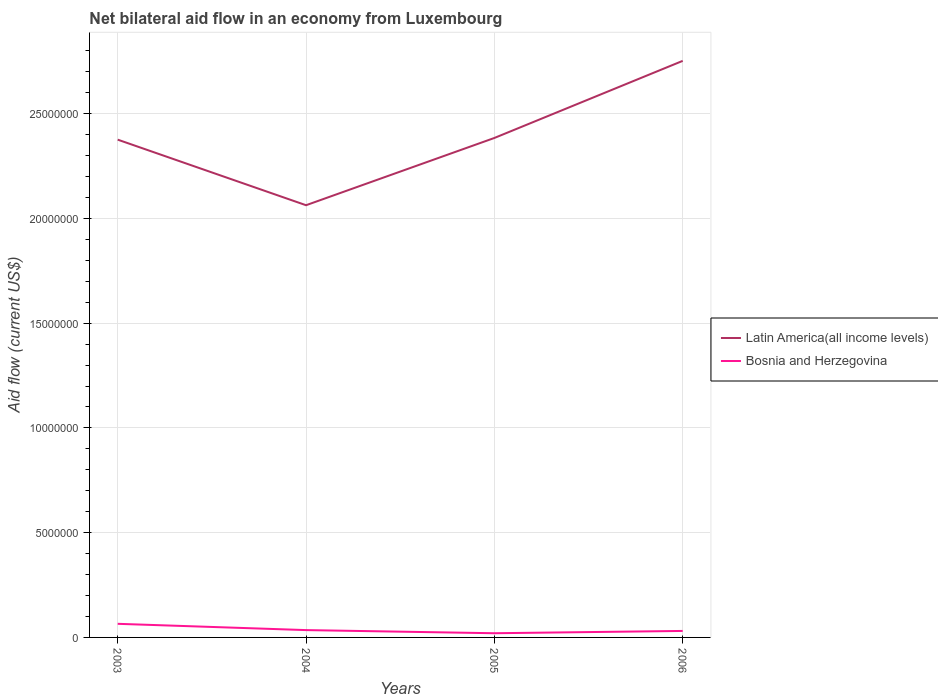Does the line corresponding to Bosnia and Herzegovina intersect with the line corresponding to Latin America(all income levels)?
Your answer should be very brief. No. Across all years, what is the maximum net bilateral aid flow in Bosnia and Herzegovina?
Provide a short and direct response. 2.00e+05. What is the total net bilateral aid flow in Bosnia and Herzegovina in the graph?
Ensure brevity in your answer.  1.50e+05. What is the difference between the highest and the second highest net bilateral aid flow in Bosnia and Herzegovina?
Give a very brief answer. 4.50e+05. What is the difference between the highest and the lowest net bilateral aid flow in Latin America(all income levels)?
Offer a very short reply. 1. Is the net bilateral aid flow in Latin America(all income levels) strictly greater than the net bilateral aid flow in Bosnia and Herzegovina over the years?
Your answer should be very brief. No. What is the difference between two consecutive major ticks on the Y-axis?
Provide a succinct answer. 5.00e+06. Does the graph contain any zero values?
Provide a succinct answer. No. Does the graph contain grids?
Provide a short and direct response. Yes. Where does the legend appear in the graph?
Keep it short and to the point. Center right. How many legend labels are there?
Keep it short and to the point. 2. What is the title of the graph?
Your answer should be compact. Net bilateral aid flow in an economy from Luxembourg. What is the label or title of the X-axis?
Your answer should be compact. Years. What is the label or title of the Y-axis?
Keep it short and to the point. Aid flow (current US$). What is the Aid flow (current US$) in Latin America(all income levels) in 2003?
Your answer should be compact. 2.38e+07. What is the Aid flow (current US$) in Bosnia and Herzegovina in 2003?
Your answer should be very brief. 6.50e+05. What is the Aid flow (current US$) of Latin America(all income levels) in 2004?
Your answer should be compact. 2.06e+07. What is the Aid flow (current US$) in Latin America(all income levels) in 2005?
Give a very brief answer. 2.38e+07. What is the Aid flow (current US$) in Bosnia and Herzegovina in 2005?
Make the answer very short. 2.00e+05. What is the Aid flow (current US$) of Latin America(all income levels) in 2006?
Your answer should be compact. 2.75e+07. Across all years, what is the maximum Aid flow (current US$) in Latin America(all income levels)?
Provide a short and direct response. 2.75e+07. Across all years, what is the maximum Aid flow (current US$) in Bosnia and Herzegovina?
Offer a very short reply. 6.50e+05. Across all years, what is the minimum Aid flow (current US$) of Latin America(all income levels)?
Provide a short and direct response. 2.06e+07. Across all years, what is the minimum Aid flow (current US$) of Bosnia and Herzegovina?
Your answer should be compact. 2.00e+05. What is the total Aid flow (current US$) in Latin America(all income levels) in the graph?
Ensure brevity in your answer.  9.58e+07. What is the total Aid flow (current US$) in Bosnia and Herzegovina in the graph?
Keep it short and to the point. 1.51e+06. What is the difference between the Aid flow (current US$) in Latin America(all income levels) in 2003 and that in 2004?
Ensure brevity in your answer.  3.13e+06. What is the difference between the Aid flow (current US$) of Bosnia and Herzegovina in 2003 and that in 2004?
Provide a short and direct response. 3.00e+05. What is the difference between the Aid flow (current US$) of Latin America(all income levels) in 2003 and that in 2006?
Keep it short and to the point. -3.76e+06. What is the difference between the Aid flow (current US$) in Bosnia and Herzegovina in 2003 and that in 2006?
Give a very brief answer. 3.40e+05. What is the difference between the Aid flow (current US$) in Latin America(all income levels) in 2004 and that in 2005?
Provide a short and direct response. -3.21e+06. What is the difference between the Aid flow (current US$) in Bosnia and Herzegovina in 2004 and that in 2005?
Provide a short and direct response. 1.50e+05. What is the difference between the Aid flow (current US$) in Latin America(all income levels) in 2004 and that in 2006?
Offer a very short reply. -6.89e+06. What is the difference between the Aid flow (current US$) of Bosnia and Herzegovina in 2004 and that in 2006?
Give a very brief answer. 4.00e+04. What is the difference between the Aid flow (current US$) of Latin America(all income levels) in 2005 and that in 2006?
Your response must be concise. -3.68e+06. What is the difference between the Aid flow (current US$) of Bosnia and Herzegovina in 2005 and that in 2006?
Provide a succinct answer. -1.10e+05. What is the difference between the Aid flow (current US$) of Latin America(all income levels) in 2003 and the Aid flow (current US$) of Bosnia and Herzegovina in 2004?
Your answer should be compact. 2.34e+07. What is the difference between the Aid flow (current US$) in Latin America(all income levels) in 2003 and the Aid flow (current US$) in Bosnia and Herzegovina in 2005?
Keep it short and to the point. 2.36e+07. What is the difference between the Aid flow (current US$) in Latin America(all income levels) in 2003 and the Aid flow (current US$) in Bosnia and Herzegovina in 2006?
Provide a succinct answer. 2.34e+07. What is the difference between the Aid flow (current US$) of Latin America(all income levels) in 2004 and the Aid flow (current US$) of Bosnia and Herzegovina in 2005?
Ensure brevity in your answer.  2.04e+07. What is the difference between the Aid flow (current US$) in Latin America(all income levels) in 2004 and the Aid flow (current US$) in Bosnia and Herzegovina in 2006?
Offer a terse response. 2.03e+07. What is the difference between the Aid flow (current US$) of Latin America(all income levels) in 2005 and the Aid flow (current US$) of Bosnia and Herzegovina in 2006?
Provide a short and direct response. 2.35e+07. What is the average Aid flow (current US$) of Latin America(all income levels) per year?
Your answer should be very brief. 2.39e+07. What is the average Aid flow (current US$) in Bosnia and Herzegovina per year?
Provide a short and direct response. 3.78e+05. In the year 2003, what is the difference between the Aid flow (current US$) of Latin America(all income levels) and Aid flow (current US$) of Bosnia and Herzegovina?
Provide a short and direct response. 2.31e+07. In the year 2004, what is the difference between the Aid flow (current US$) of Latin America(all income levels) and Aid flow (current US$) of Bosnia and Herzegovina?
Keep it short and to the point. 2.03e+07. In the year 2005, what is the difference between the Aid flow (current US$) in Latin America(all income levels) and Aid flow (current US$) in Bosnia and Herzegovina?
Ensure brevity in your answer.  2.36e+07. In the year 2006, what is the difference between the Aid flow (current US$) in Latin America(all income levels) and Aid flow (current US$) in Bosnia and Herzegovina?
Give a very brief answer. 2.72e+07. What is the ratio of the Aid flow (current US$) of Latin America(all income levels) in 2003 to that in 2004?
Keep it short and to the point. 1.15. What is the ratio of the Aid flow (current US$) of Bosnia and Herzegovina in 2003 to that in 2004?
Your answer should be compact. 1.86. What is the ratio of the Aid flow (current US$) in Bosnia and Herzegovina in 2003 to that in 2005?
Ensure brevity in your answer.  3.25. What is the ratio of the Aid flow (current US$) in Latin America(all income levels) in 2003 to that in 2006?
Your response must be concise. 0.86. What is the ratio of the Aid flow (current US$) in Bosnia and Herzegovina in 2003 to that in 2006?
Offer a very short reply. 2.1. What is the ratio of the Aid flow (current US$) of Latin America(all income levels) in 2004 to that in 2005?
Ensure brevity in your answer.  0.87. What is the ratio of the Aid flow (current US$) of Latin America(all income levels) in 2004 to that in 2006?
Your answer should be compact. 0.75. What is the ratio of the Aid flow (current US$) in Bosnia and Herzegovina in 2004 to that in 2006?
Make the answer very short. 1.13. What is the ratio of the Aid flow (current US$) of Latin America(all income levels) in 2005 to that in 2006?
Offer a very short reply. 0.87. What is the ratio of the Aid flow (current US$) of Bosnia and Herzegovina in 2005 to that in 2006?
Offer a terse response. 0.65. What is the difference between the highest and the second highest Aid flow (current US$) of Latin America(all income levels)?
Ensure brevity in your answer.  3.68e+06. What is the difference between the highest and the second highest Aid flow (current US$) in Bosnia and Herzegovina?
Ensure brevity in your answer.  3.00e+05. What is the difference between the highest and the lowest Aid flow (current US$) of Latin America(all income levels)?
Provide a succinct answer. 6.89e+06. What is the difference between the highest and the lowest Aid flow (current US$) of Bosnia and Herzegovina?
Provide a succinct answer. 4.50e+05. 